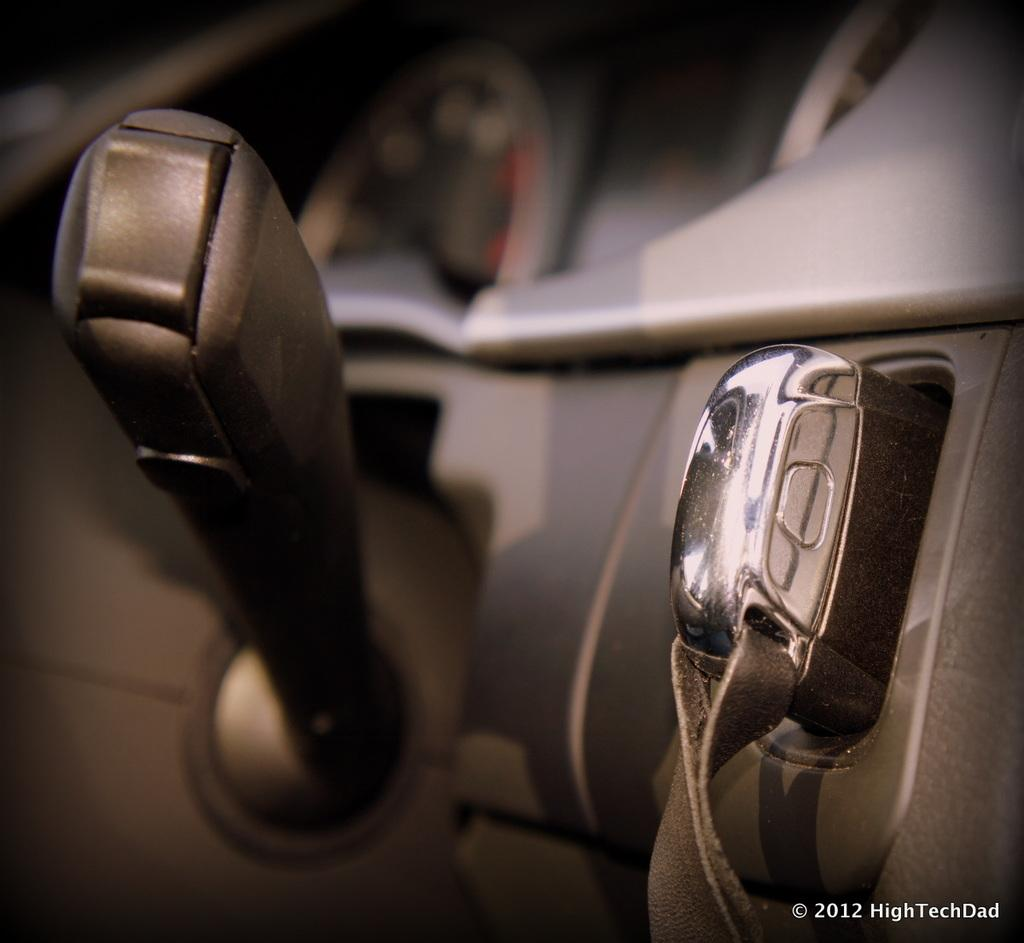What type of location is depicted in the image? The image shows the inside of a vehicle. What can be found in the middle of the image? There is a key and switch stalk in the middle of the image. What instrument is visible at the top of the image? There is a speedometer visible at the top of the image. Can you see a robin perched on the speedometer in the image? No, there is no robin present in the image. Is there any water visible in the image? No, there is no water visible in the image. 